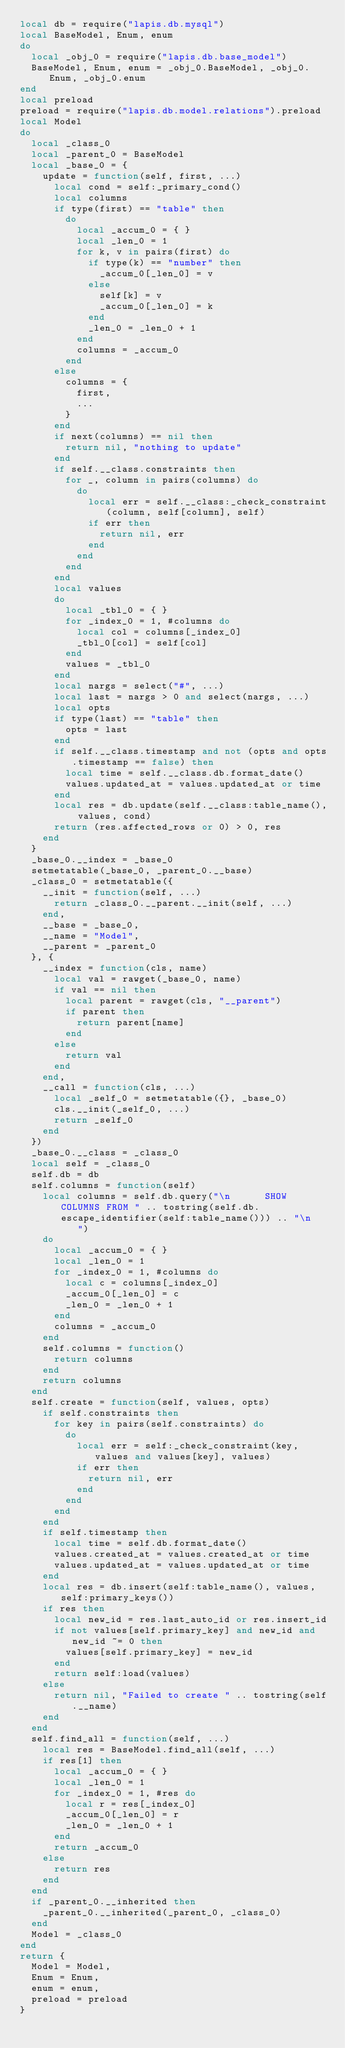<code> <loc_0><loc_0><loc_500><loc_500><_Lua_>local db = require("lapis.db.mysql")
local BaseModel, Enum, enum
do
  local _obj_0 = require("lapis.db.base_model")
  BaseModel, Enum, enum = _obj_0.BaseModel, _obj_0.Enum, _obj_0.enum
end
local preload
preload = require("lapis.db.model.relations").preload
local Model
do
  local _class_0
  local _parent_0 = BaseModel
  local _base_0 = {
    update = function(self, first, ...)
      local cond = self:_primary_cond()
      local columns
      if type(first) == "table" then
        do
          local _accum_0 = { }
          local _len_0 = 1
          for k, v in pairs(first) do
            if type(k) == "number" then
              _accum_0[_len_0] = v
            else
              self[k] = v
              _accum_0[_len_0] = k
            end
            _len_0 = _len_0 + 1
          end
          columns = _accum_0
        end
      else
        columns = {
          first,
          ...
        }
      end
      if next(columns) == nil then
        return nil, "nothing to update"
      end
      if self.__class.constraints then
        for _, column in pairs(columns) do
          do
            local err = self.__class:_check_constraint(column, self[column], self)
            if err then
              return nil, err
            end
          end
        end
      end
      local values
      do
        local _tbl_0 = { }
        for _index_0 = 1, #columns do
          local col = columns[_index_0]
          _tbl_0[col] = self[col]
        end
        values = _tbl_0
      end
      local nargs = select("#", ...)
      local last = nargs > 0 and select(nargs, ...)
      local opts
      if type(last) == "table" then
        opts = last
      end
      if self.__class.timestamp and not (opts and opts.timestamp == false) then
        local time = self.__class.db.format_date()
        values.updated_at = values.updated_at or time
      end
      local res = db.update(self.__class:table_name(), values, cond)
      return (res.affected_rows or 0) > 0, res
    end
  }
  _base_0.__index = _base_0
  setmetatable(_base_0, _parent_0.__base)
  _class_0 = setmetatable({
    __init = function(self, ...)
      return _class_0.__parent.__init(self, ...)
    end,
    __base = _base_0,
    __name = "Model",
    __parent = _parent_0
  }, {
    __index = function(cls, name)
      local val = rawget(_base_0, name)
      if val == nil then
        local parent = rawget(cls, "__parent")
        if parent then
          return parent[name]
        end
      else
        return val
      end
    end,
    __call = function(cls, ...)
      local _self_0 = setmetatable({}, _base_0)
      cls.__init(_self_0, ...)
      return _self_0
    end
  })
  _base_0.__class = _class_0
  local self = _class_0
  self.db = db
  self.columns = function(self)
    local columns = self.db.query("\n      SHOW COLUMNS FROM " .. tostring(self.db.escape_identifier(self:table_name())) .. "\n    ")
    do
      local _accum_0 = { }
      local _len_0 = 1
      for _index_0 = 1, #columns do
        local c = columns[_index_0]
        _accum_0[_len_0] = c
        _len_0 = _len_0 + 1
      end
      columns = _accum_0
    end
    self.columns = function()
      return columns
    end
    return columns
  end
  self.create = function(self, values, opts)
    if self.constraints then
      for key in pairs(self.constraints) do
        do
          local err = self:_check_constraint(key, values and values[key], values)
          if err then
            return nil, err
          end
        end
      end
    end
    if self.timestamp then
      local time = self.db.format_date()
      values.created_at = values.created_at or time
      values.updated_at = values.updated_at or time
    end
    local res = db.insert(self:table_name(), values, self:primary_keys())
    if res then
      local new_id = res.last_auto_id or res.insert_id
      if not values[self.primary_key] and new_id and new_id ~= 0 then
        values[self.primary_key] = new_id
      end
      return self:load(values)
    else
      return nil, "Failed to create " .. tostring(self.__name)
    end
  end
  self.find_all = function(self, ...)
    local res = BaseModel.find_all(self, ...)
    if res[1] then
      local _accum_0 = { }
      local _len_0 = 1
      for _index_0 = 1, #res do
        local r = res[_index_0]
        _accum_0[_len_0] = r
        _len_0 = _len_0 + 1
      end
      return _accum_0
    else
      return res
    end
  end
  if _parent_0.__inherited then
    _parent_0.__inherited(_parent_0, _class_0)
  end
  Model = _class_0
end
return {
  Model = Model,
  Enum = Enum,
  enum = enum,
  preload = preload
}
</code> 